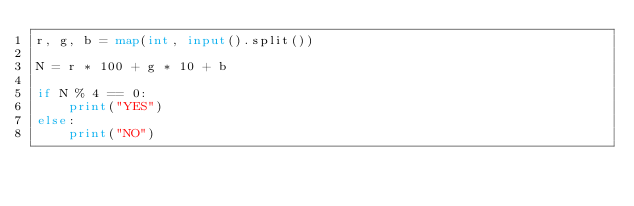<code> <loc_0><loc_0><loc_500><loc_500><_Python_>r, g, b = map(int, input().split())

N = r * 100 + g * 10 + b

if N % 4 == 0:
    print("YES")
else:
    print("NO")</code> 